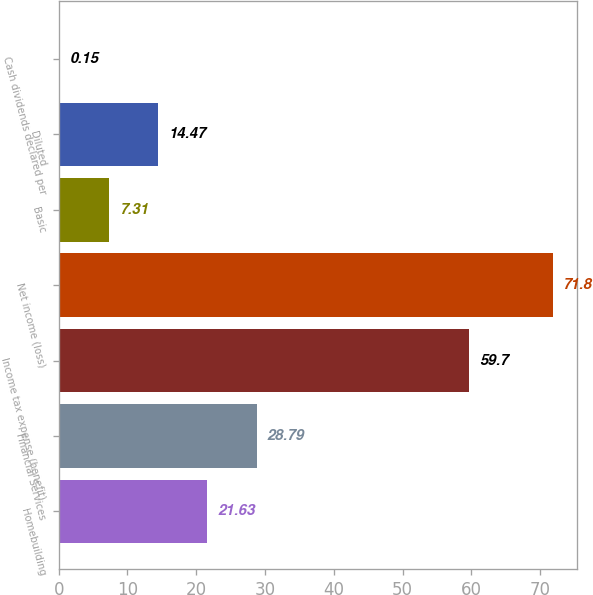<chart> <loc_0><loc_0><loc_500><loc_500><bar_chart><fcel>Homebuilding<fcel>Financial Services<fcel>Income tax expense (benefit)<fcel>Net income (loss)<fcel>Basic<fcel>Diluted<fcel>Cash dividends declared per<nl><fcel>21.63<fcel>28.79<fcel>59.7<fcel>71.8<fcel>7.31<fcel>14.47<fcel>0.15<nl></chart> 